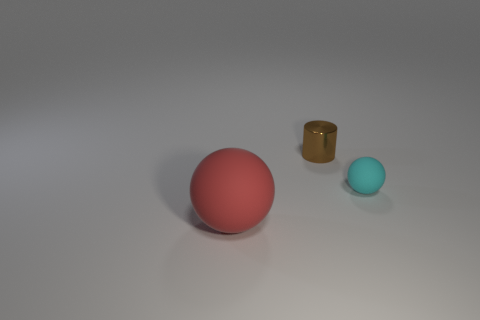How many tiny cyan things have the same material as the big red thing?
Keep it short and to the point. 1. How many objects are matte balls or things that are behind the small cyan rubber ball?
Provide a succinct answer. 3. The small object behind the matte ball behind the thing that is on the left side of the tiny brown shiny cylinder is what color?
Your response must be concise. Brown. What size is the matte thing that is in front of the tiny cyan thing?
Your answer should be very brief. Large. What number of small things are red balls or purple objects?
Make the answer very short. 0. What is the color of the thing that is behind the large red matte object and in front of the metallic cylinder?
Keep it short and to the point. Cyan. Are there any small cyan matte things that have the same shape as the big red rubber thing?
Offer a terse response. Yes. What is the material of the tiny brown thing?
Give a very brief answer. Metal. There is a large thing; are there any small brown cylinders to the right of it?
Ensure brevity in your answer.  Yes. Is the tiny matte thing the same shape as the big red thing?
Your answer should be very brief. Yes. 